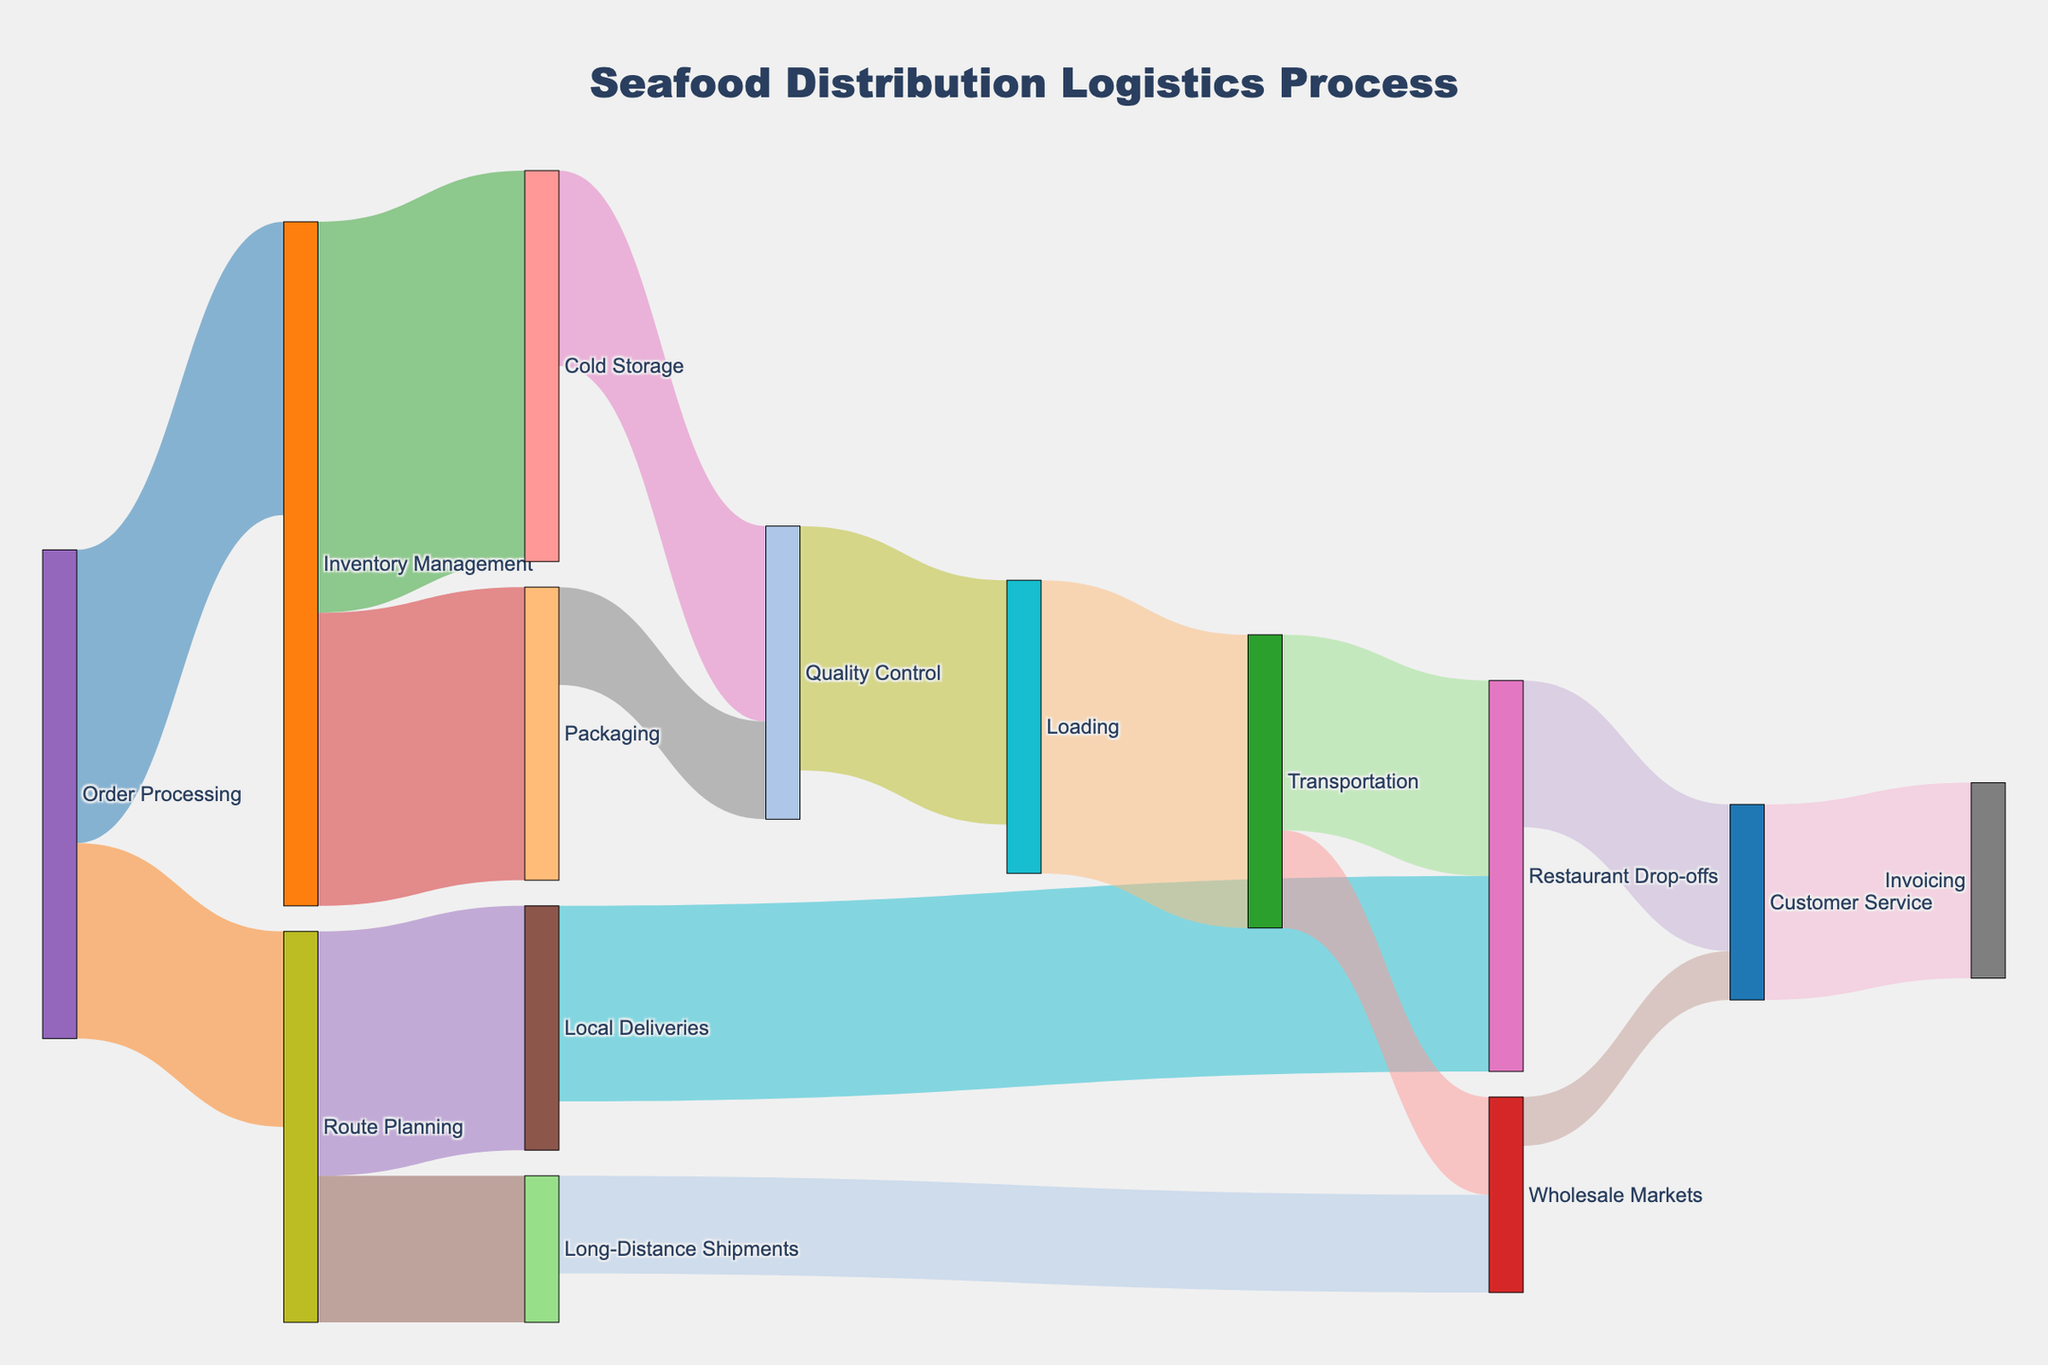What is the main title of the Sankey diagram? The main title is usually positioned at the top center of the diagram. In this case, the title given in the code is "Seafood Distribution Logistics Process".
Answer: Seafood Distribution Logistics Process Which task has the highest allocation from "Order Processing"? Look for the task with the largest allocated value flowing out from "Order Processing". "Inventory Management" has a value of 3, compared to "Route Planning" with a value of 2.
Answer: Inventory Management How many total hours are allocated to "Quality Control"? Sum the incoming values directed towards "Quality Control". These are 2 from "Cold Storage" and 1 from "Packaging", making a total of 3.
Answer: 3 Which task receives more time from "Route Planning", "Local Deliveries" or "Long-Distance Shipments"? Compare the values from "Route Planning" to both "Local Deliveries" and "Long-Distance Shipments". "Local Deliveries" receives 2.5 while "Long-Distance Shipments" receives 1.5.
Answer: Local Deliveries What is the total time allocation for "Customer Service"? Add the time allocated from both "Restaurant Drop-offs" and "Wholesale Markets" to "Customer Service". These are 1.5 and 0.5, respectively, making a total of 2.
Answer: 2 What is the value allocated to "Cold Storage"? Check the flow from "Inventory Management" to "Cold Storage". The value is 4.
Answer: 4 From which source does "Restaurant Drop-offs" receive more time, "Local Deliveries" or "Transportation"? Compare the values directed to "Restaurant Drop-offs". "Local Deliveries" allocates 2 and "Transportation" allocates 2 as well, making it equal.
Answer: Equal Which tasks involve "Inventory Management"? Identify the tasks connected to "Inventory Management". They are "Cold Storage" (4) and "Packaging" (3).
Answer: Cold Storage, Packaging What is the sum of time allocations for "Loading"? Look at the flows directed to and from "Loading". The incoming from "Quality Control" is 2.5 and it allocates 3 to "Transportation". The focus is on the incoming side.
Answer: 2.5 Compare the combined time allocation from "Order Processing" to "Route Planning" and from "Route Planning" to "Local Deliveries" against the time allocation from "Order Processing" to "Inventory Management". Which is higher? Combine the allocations from "Order Processing" to "Route Planning" (2) and "Route Planning" to "Local Deliveries" (2.5) which is 4.5. This is compared with "Order Processing" to "Inventory Management" which is 3.
Answer: Combined allocations (4.5) 